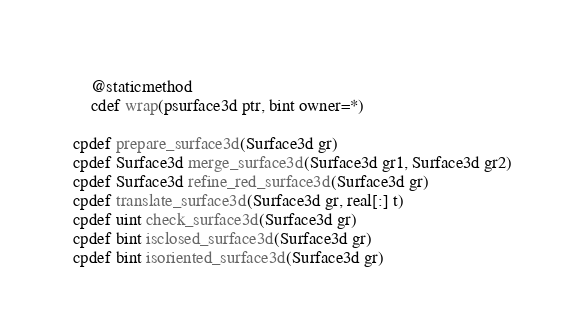<code> <loc_0><loc_0><loc_500><loc_500><_Cython_>    @staticmethod
    cdef wrap(psurface3d ptr, bint owner=*)

cpdef prepare_surface3d(Surface3d gr)
cpdef Surface3d merge_surface3d(Surface3d gr1, Surface3d gr2)
cpdef Surface3d refine_red_surface3d(Surface3d gr)
cpdef translate_surface3d(Surface3d gr, real[:] t)
cpdef uint check_surface3d(Surface3d gr)
cpdef bint isclosed_surface3d(Surface3d gr)
cpdef bint isoriented_surface3d(Surface3d gr)</code> 